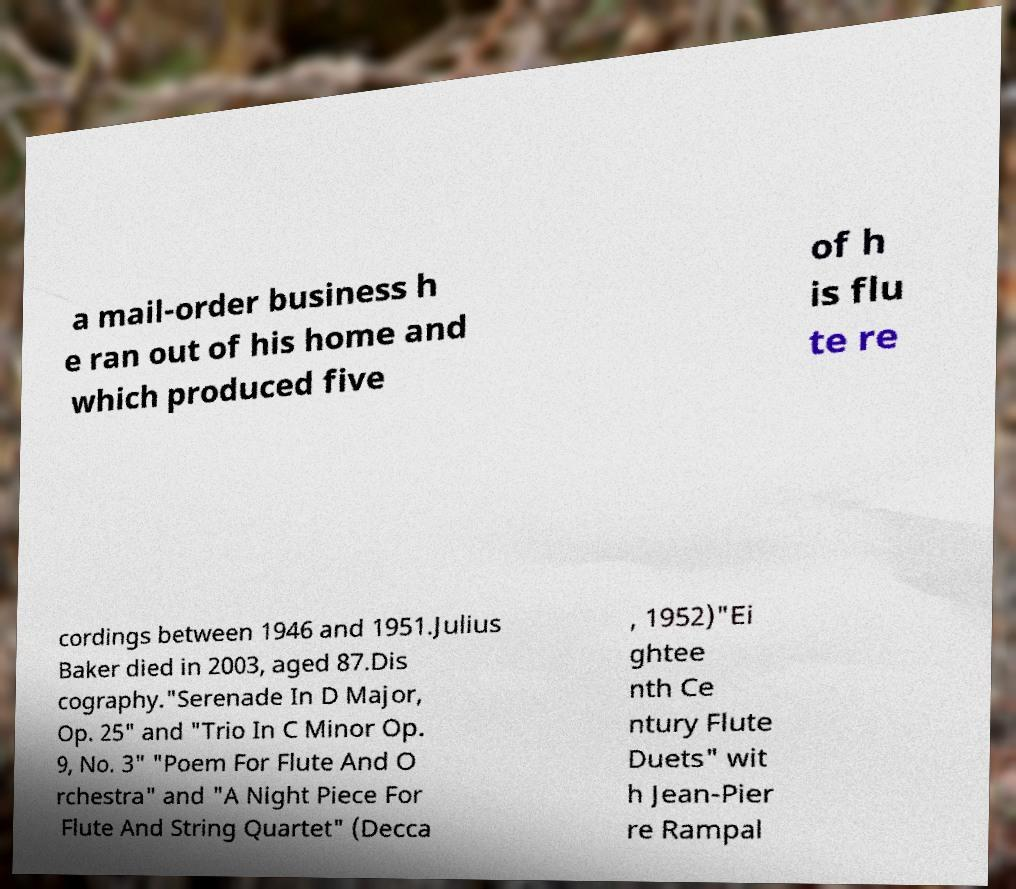Please read and relay the text visible in this image. What does it say? a mail-order business h e ran out of his home and which produced five of h is flu te re cordings between 1946 and 1951.Julius Baker died in 2003, aged 87.Dis cography."Serenade In D Major, Op. 25" and "Trio In C Minor Op. 9, No. 3" "Poem For Flute And O rchestra" and "A Night Piece For Flute And String Quartet" (Decca , 1952)"Ei ghtee nth Ce ntury Flute Duets" wit h Jean-Pier re Rampal 